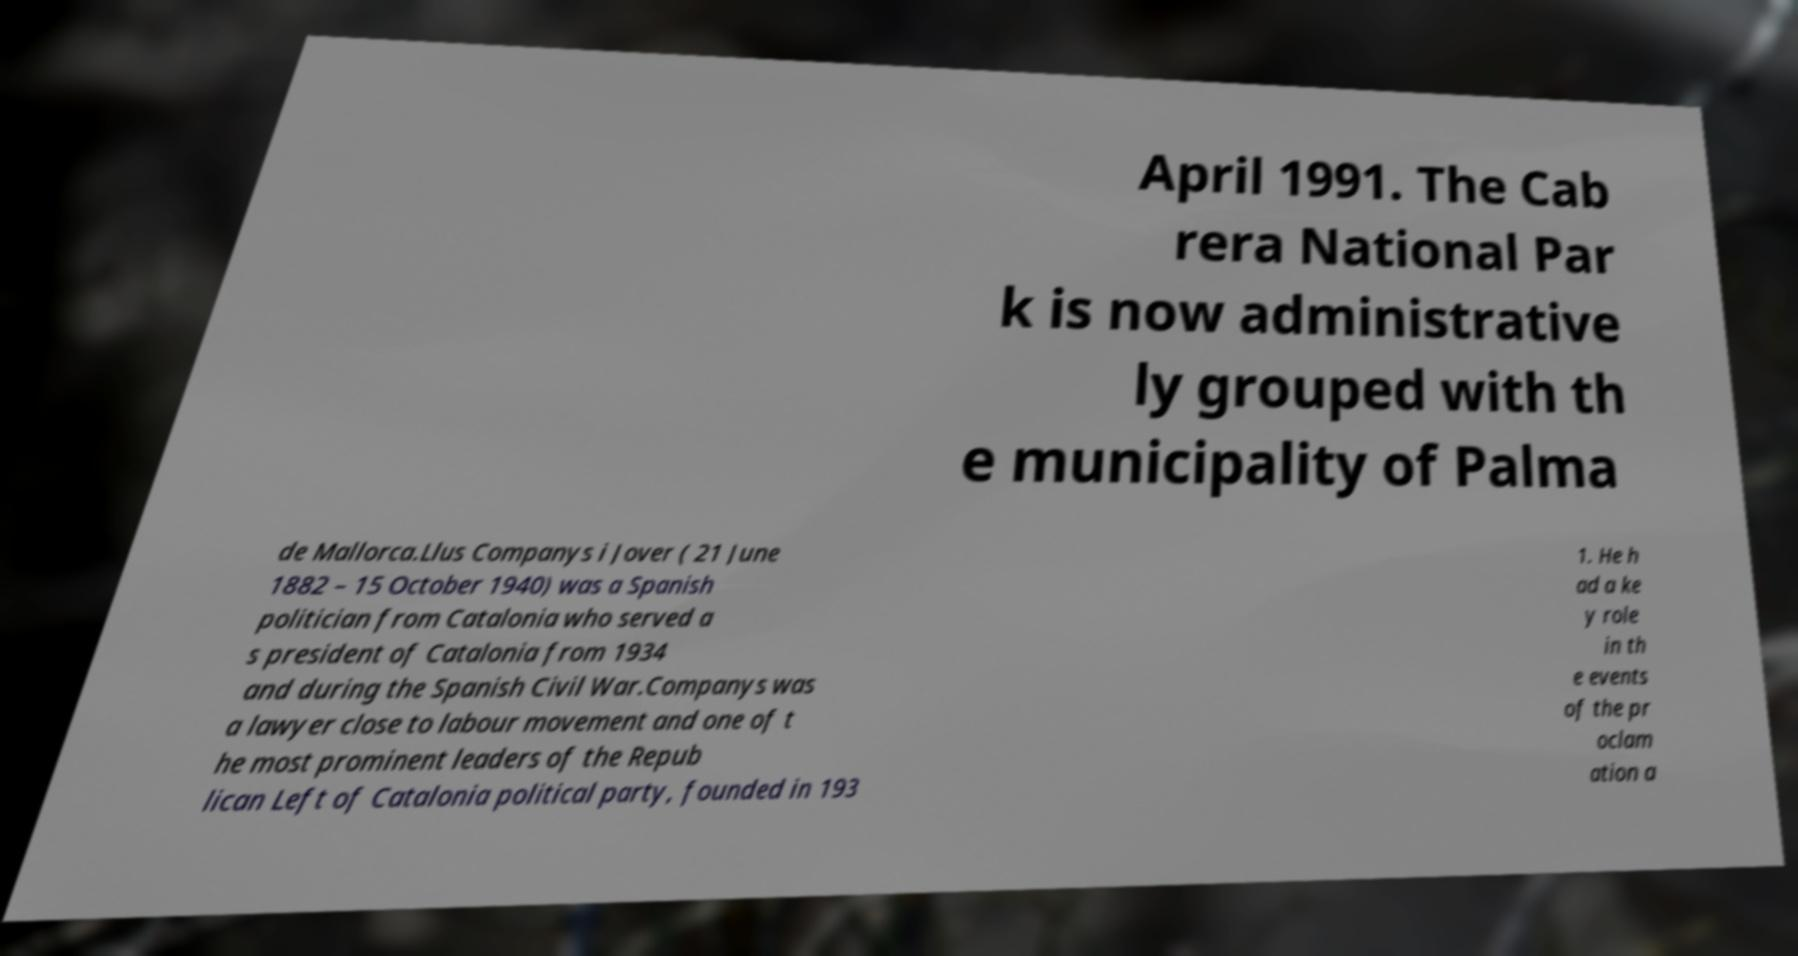For documentation purposes, I need the text within this image transcribed. Could you provide that? April 1991. The Cab rera National Par k is now administrative ly grouped with th e municipality of Palma de Mallorca.Llus Companys i Jover ( 21 June 1882 – 15 October 1940) was a Spanish politician from Catalonia who served a s president of Catalonia from 1934 and during the Spanish Civil War.Companys was a lawyer close to labour movement and one of t he most prominent leaders of the Repub lican Left of Catalonia political party, founded in 193 1. He h ad a ke y role in th e events of the pr oclam ation a 